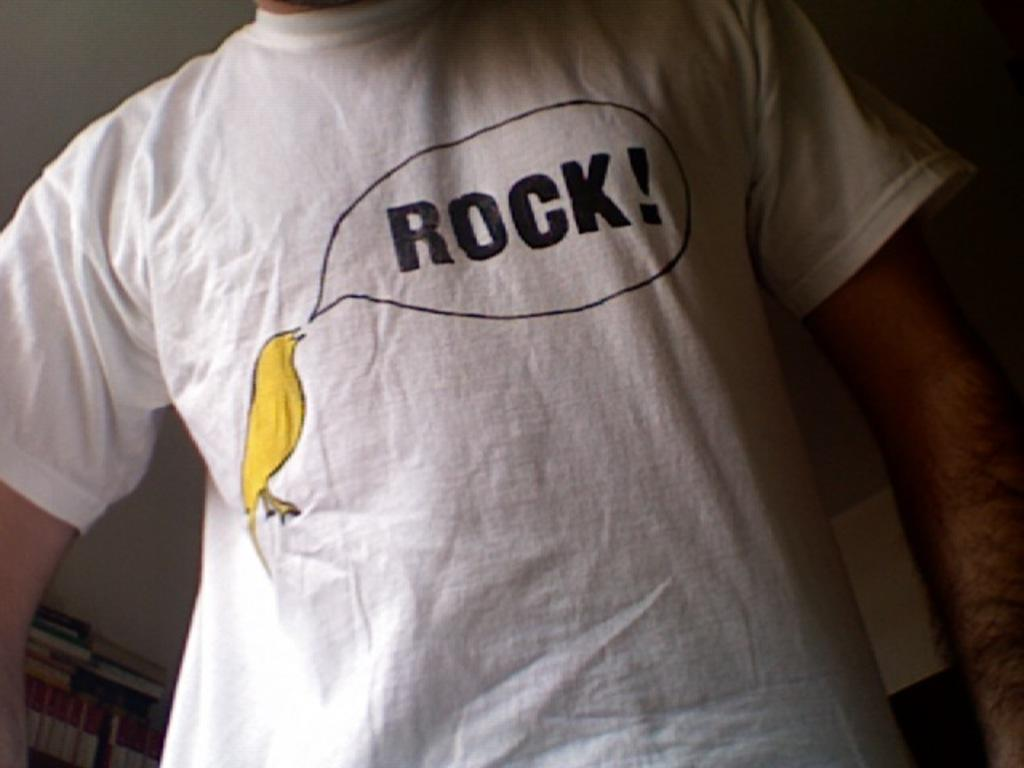Provide a one-sentence caption for the provided image. A white t-shirt shows a yellow bird saying "rock!". 